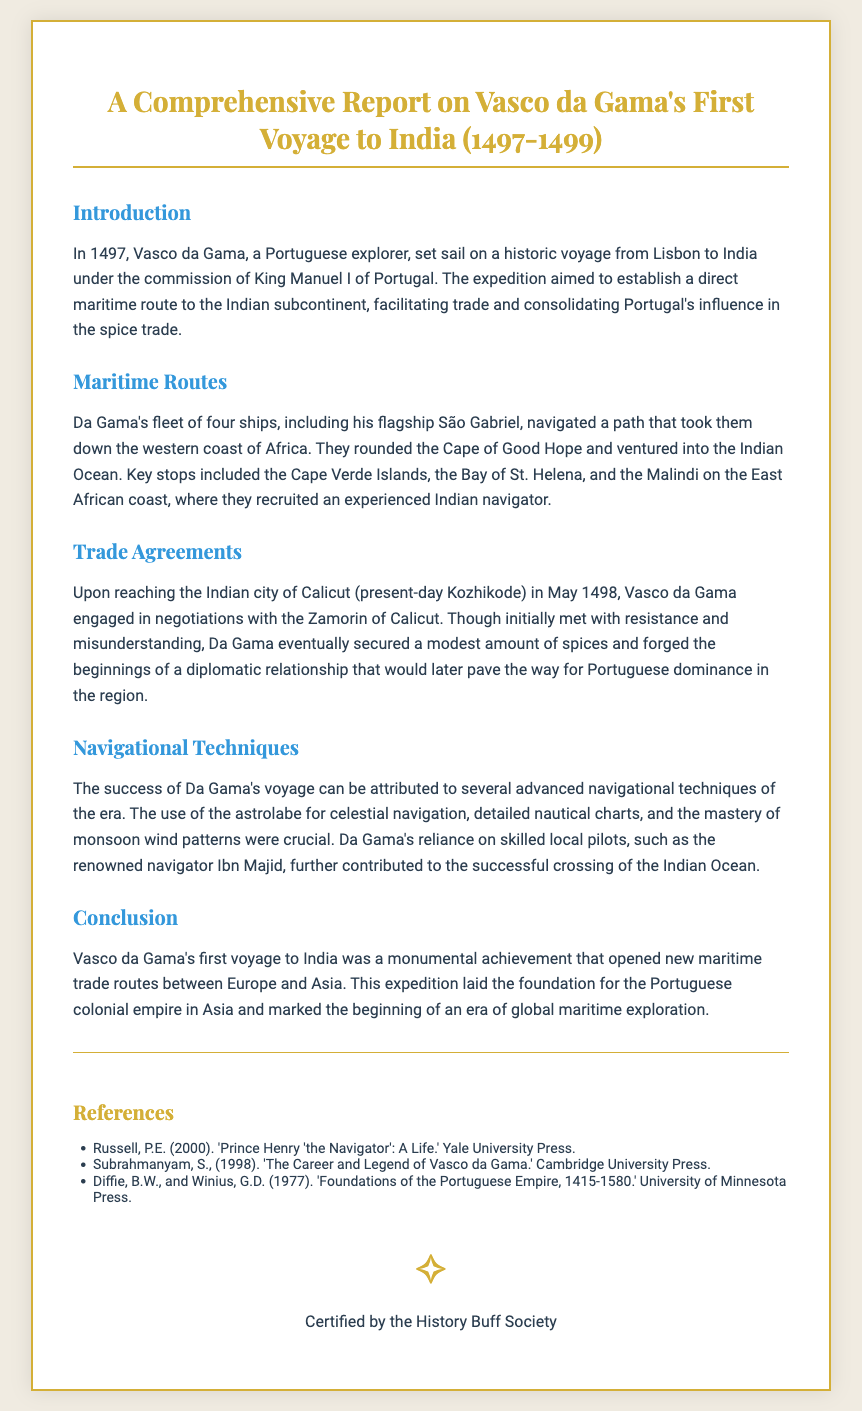What year did Vasco da Gama set sail on his first voyage? The document states that Vasco da Gama set sail in 1497 for his historic voyage.
Answer: 1497 What was the name of Vasco da Gama's flagship? The report mentions that the flagship of Vasco da Gama was the São Gabriel.
Answer: São Gabriel Which Indian city did Vasco da Gama reach in May 1498? The document specifies that Vasco da Gama reached the city of Calicut in May 1498.
Answer: Calicut What navigational tool did Da Gama use for celestial navigation? According to the document, Da Gama relied on the astrolabe for celestial navigation.
Answer: Astrolabe Why was the recruitment of an experienced navigator important for the voyage? The document emphasizes that the recruitment of an experienced Indian navigator was crucial for successful navigation in the Indian Ocean.
Answer: Successful navigation What was the initial outcome of Da Gama's negotiations with the Zamorin of Calicut? The report highlights that Da Gama was initially met with resistance and misunderstanding in his negotiations.
Answer: Resistance and misunderstanding Which two navigational techniques contributed to the success of the voyage? The document lists the astrolabe and understanding monsoon wind patterns as techniques that contributed to the voyage's success.
Answer: Astrolabe and monsoon wind patterns What was the ultimate goal of Vasco da Gama's voyage? The document states that the expedition aimed to establish a direct maritime route for trade with the Indian subcontinent.
Answer: Establishing a direct maritime route What recognition was provided at the end of the diploma? The document concludes with a certification statement by the History Buff Society.
Answer: Certified by the History Buff Society 